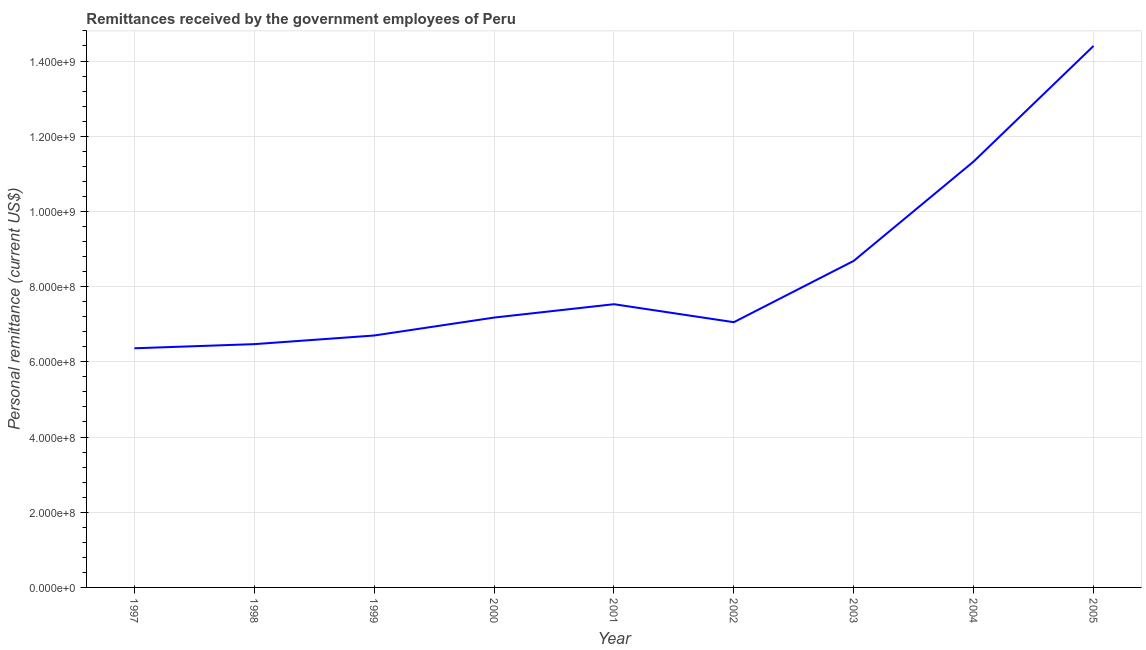What is the personal remittances in 2000?
Give a very brief answer. 7.18e+08. Across all years, what is the maximum personal remittances?
Offer a terse response. 1.44e+09. Across all years, what is the minimum personal remittances?
Give a very brief answer. 6.36e+08. In which year was the personal remittances maximum?
Ensure brevity in your answer.  2005. In which year was the personal remittances minimum?
Provide a succinct answer. 1997. What is the sum of the personal remittances?
Your answer should be very brief. 7.57e+09. What is the difference between the personal remittances in 2001 and 2003?
Offer a terse response. -1.15e+08. What is the average personal remittances per year?
Provide a succinct answer. 8.41e+08. What is the median personal remittances?
Make the answer very short. 7.18e+08. What is the ratio of the personal remittances in 1997 to that in 2001?
Provide a succinct answer. 0.84. Is the personal remittances in 1997 less than that in 2004?
Provide a succinct answer. Yes. Is the difference between the personal remittances in 1997 and 1999 greater than the difference between any two years?
Provide a short and direct response. No. What is the difference between the highest and the second highest personal remittances?
Provide a succinct answer. 3.07e+08. Is the sum of the personal remittances in 2001 and 2004 greater than the maximum personal remittances across all years?
Your response must be concise. Yes. What is the difference between the highest and the lowest personal remittances?
Provide a succinct answer. 8.04e+08. In how many years, is the personal remittances greater than the average personal remittances taken over all years?
Provide a succinct answer. 3. Does the personal remittances monotonically increase over the years?
Offer a very short reply. No. What is the title of the graph?
Your response must be concise. Remittances received by the government employees of Peru. What is the label or title of the Y-axis?
Offer a very short reply. Personal remittance (current US$). What is the Personal remittance (current US$) of 1997?
Offer a very short reply. 6.36e+08. What is the Personal remittance (current US$) in 1998?
Your response must be concise. 6.47e+08. What is the Personal remittance (current US$) in 1999?
Your response must be concise. 6.70e+08. What is the Personal remittance (current US$) of 2000?
Your response must be concise. 7.18e+08. What is the Personal remittance (current US$) of 2001?
Keep it short and to the point. 7.53e+08. What is the Personal remittance (current US$) in 2002?
Make the answer very short. 7.05e+08. What is the Personal remittance (current US$) in 2003?
Provide a succinct answer. 8.68e+08. What is the Personal remittance (current US$) in 2004?
Offer a terse response. 1.13e+09. What is the Personal remittance (current US$) in 2005?
Your answer should be very brief. 1.44e+09. What is the difference between the Personal remittance (current US$) in 1997 and 1998?
Make the answer very short. -1.10e+07. What is the difference between the Personal remittance (current US$) in 1997 and 1999?
Give a very brief answer. -3.40e+07. What is the difference between the Personal remittance (current US$) in 1997 and 2000?
Ensure brevity in your answer.  -8.17e+07. What is the difference between the Personal remittance (current US$) in 1997 and 2001?
Provide a short and direct response. -1.17e+08. What is the difference between the Personal remittance (current US$) in 1997 and 2002?
Your answer should be very brief. -6.94e+07. What is the difference between the Personal remittance (current US$) in 1997 and 2003?
Offer a very short reply. -2.32e+08. What is the difference between the Personal remittance (current US$) in 1997 and 2004?
Provide a short and direct response. -4.97e+08. What is the difference between the Personal remittance (current US$) in 1997 and 2005?
Your answer should be compact. -8.04e+08. What is the difference between the Personal remittance (current US$) in 1998 and 1999?
Offer a very short reply. -2.30e+07. What is the difference between the Personal remittance (current US$) in 1998 and 2000?
Ensure brevity in your answer.  -7.07e+07. What is the difference between the Personal remittance (current US$) in 1998 and 2001?
Ensure brevity in your answer.  -1.06e+08. What is the difference between the Personal remittance (current US$) in 1998 and 2002?
Give a very brief answer. -5.84e+07. What is the difference between the Personal remittance (current US$) in 1998 and 2003?
Give a very brief answer. -2.22e+08. What is the difference between the Personal remittance (current US$) in 1998 and 2004?
Provide a succinct answer. -4.86e+08. What is the difference between the Personal remittance (current US$) in 1998 and 2005?
Your answer should be very brief. -7.93e+08. What is the difference between the Personal remittance (current US$) in 1999 and 2000?
Your answer should be compact. -4.77e+07. What is the difference between the Personal remittance (current US$) in 1999 and 2001?
Keep it short and to the point. -8.32e+07. What is the difference between the Personal remittance (current US$) in 1999 and 2002?
Your response must be concise. -3.54e+07. What is the difference between the Personal remittance (current US$) in 1999 and 2003?
Ensure brevity in your answer.  -1.98e+08. What is the difference between the Personal remittance (current US$) in 1999 and 2004?
Give a very brief answer. -4.63e+08. What is the difference between the Personal remittance (current US$) in 1999 and 2005?
Offer a very short reply. -7.70e+08. What is the difference between the Personal remittance (current US$) in 2000 and 2001?
Your answer should be compact. -3.55e+07. What is the difference between the Personal remittance (current US$) in 2000 and 2002?
Offer a terse response. 1.23e+07. What is the difference between the Personal remittance (current US$) in 2000 and 2003?
Provide a short and direct response. -1.51e+08. What is the difference between the Personal remittance (current US$) in 2000 and 2004?
Offer a terse response. -4.15e+08. What is the difference between the Personal remittance (current US$) in 2000 and 2005?
Your answer should be compact. -7.22e+08. What is the difference between the Personal remittance (current US$) in 2001 and 2002?
Provide a short and direct response. 4.78e+07. What is the difference between the Personal remittance (current US$) in 2001 and 2003?
Keep it short and to the point. -1.15e+08. What is the difference between the Personal remittance (current US$) in 2001 and 2004?
Give a very brief answer. -3.80e+08. What is the difference between the Personal remittance (current US$) in 2001 and 2005?
Provide a short and direct response. -6.87e+08. What is the difference between the Personal remittance (current US$) in 2002 and 2003?
Offer a very short reply. -1.63e+08. What is the difference between the Personal remittance (current US$) in 2002 and 2004?
Offer a terse response. -4.27e+08. What is the difference between the Personal remittance (current US$) in 2002 and 2005?
Give a very brief answer. -7.35e+08. What is the difference between the Personal remittance (current US$) in 2003 and 2004?
Provide a short and direct response. -2.64e+08. What is the difference between the Personal remittance (current US$) in 2003 and 2005?
Offer a terse response. -5.72e+08. What is the difference between the Personal remittance (current US$) in 2004 and 2005?
Offer a terse response. -3.07e+08. What is the ratio of the Personal remittance (current US$) in 1997 to that in 1999?
Your response must be concise. 0.95. What is the ratio of the Personal remittance (current US$) in 1997 to that in 2000?
Your answer should be very brief. 0.89. What is the ratio of the Personal remittance (current US$) in 1997 to that in 2001?
Provide a succinct answer. 0.84. What is the ratio of the Personal remittance (current US$) in 1997 to that in 2002?
Your response must be concise. 0.9. What is the ratio of the Personal remittance (current US$) in 1997 to that in 2003?
Your answer should be compact. 0.73. What is the ratio of the Personal remittance (current US$) in 1997 to that in 2004?
Provide a short and direct response. 0.56. What is the ratio of the Personal remittance (current US$) in 1997 to that in 2005?
Offer a terse response. 0.44. What is the ratio of the Personal remittance (current US$) in 1998 to that in 1999?
Ensure brevity in your answer.  0.97. What is the ratio of the Personal remittance (current US$) in 1998 to that in 2000?
Keep it short and to the point. 0.9. What is the ratio of the Personal remittance (current US$) in 1998 to that in 2001?
Give a very brief answer. 0.86. What is the ratio of the Personal remittance (current US$) in 1998 to that in 2002?
Your answer should be very brief. 0.92. What is the ratio of the Personal remittance (current US$) in 1998 to that in 2003?
Keep it short and to the point. 0.74. What is the ratio of the Personal remittance (current US$) in 1998 to that in 2004?
Make the answer very short. 0.57. What is the ratio of the Personal remittance (current US$) in 1998 to that in 2005?
Your response must be concise. 0.45. What is the ratio of the Personal remittance (current US$) in 1999 to that in 2000?
Your answer should be compact. 0.93. What is the ratio of the Personal remittance (current US$) in 1999 to that in 2001?
Give a very brief answer. 0.89. What is the ratio of the Personal remittance (current US$) in 1999 to that in 2003?
Give a very brief answer. 0.77. What is the ratio of the Personal remittance (current US$) in 1999 to that in 2004?
Offer a very short reply. 0.59. What is the ratio of the Personal remittance (current US$) in 1999 to that in 2005?
Make the answer very short. 0.47. What is the ratio of the Personal remittance (current US$) in 2000 to that in 2001?
Make the answer very short. 0.95. What is the ratio of the Personal remittance (current US$) in 2000 to that in 2002?
Your response must be concise. 1.02. What is the ratio of the Personal remittance (current US$) in 2000 to that in 2003?
Offer a terse response. 0.83. What is the ratio of the Personal remittance (current US$) in 2000 to that in 2004?
Provide a succinct answer. 0.63. What is the ratio of the Personal remittance (current US$) in 2000 to that in 2005?
Provide a succinct answer. 0.5. What is the ratio of the Personal remittance (current US$) in 2001 to that in 2002?
Offer a very short reply. 1.07. What is the ratio of the Personal remittance (current US$) in 2001 to that in 2003?
Your answer should be compact. 0.87. What is the ratio of the Personal remittance (current US$) in 2001 to that in 2004?
Provide a succinct answer. 0.67. What is the ratio of the Personal remittance (current US$) in 2001 to that in 2005?
Your response must be concise. 0.52. What is the ratio of the Personal remittance (current US$) in 2002 to that in 2003?
Give a very brief answer. 0.81. What is the ratio of the Personal remittance (current US$) in 2002 to that in 2004?
Provide a short and direct response. 0.62. What is the ratio of the Personal remittance (current US$) in 2002 to that in 2005?
Provide a succinct answer. 0.49. What is the ratio of the Personal remittance (current US$) in 2003 to that in 2004?
Your answer should be compact. 0.77. What is the ratio of the Personal remittance (current US$) in 2003 to that in 2005?
Offer a very short reply. 0.6. What is the ratio of the Personal remittance (current US$) in 2004 to that in 2005?
Your answer should be compact. 0.79. 